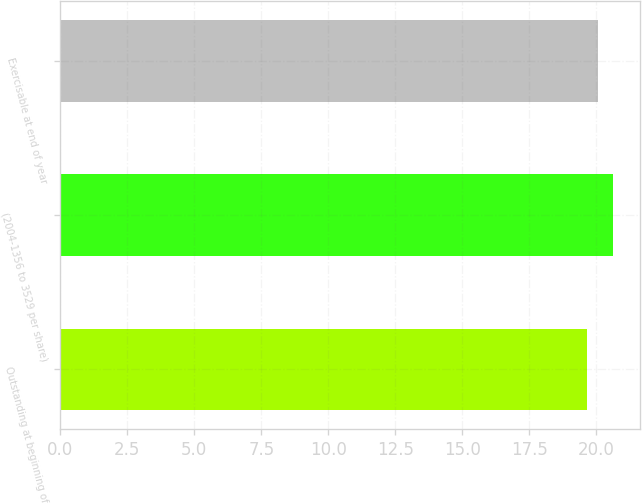Convert chart to OTSL. <chart><loc_0><loc_0><loc_500><loc_500><bar_chart><fcel>Outstanding at beginning of<fcel>(2004-1356 to 3529 per share)<fcel>Exercisable at end of year<nl><fcel>19.67<fcel>20.61<fcel>20.06<nl></chart> 